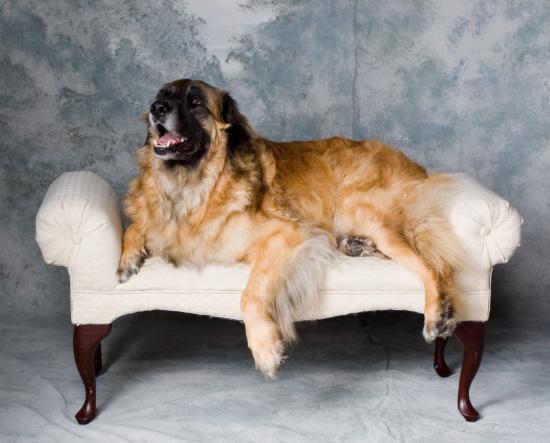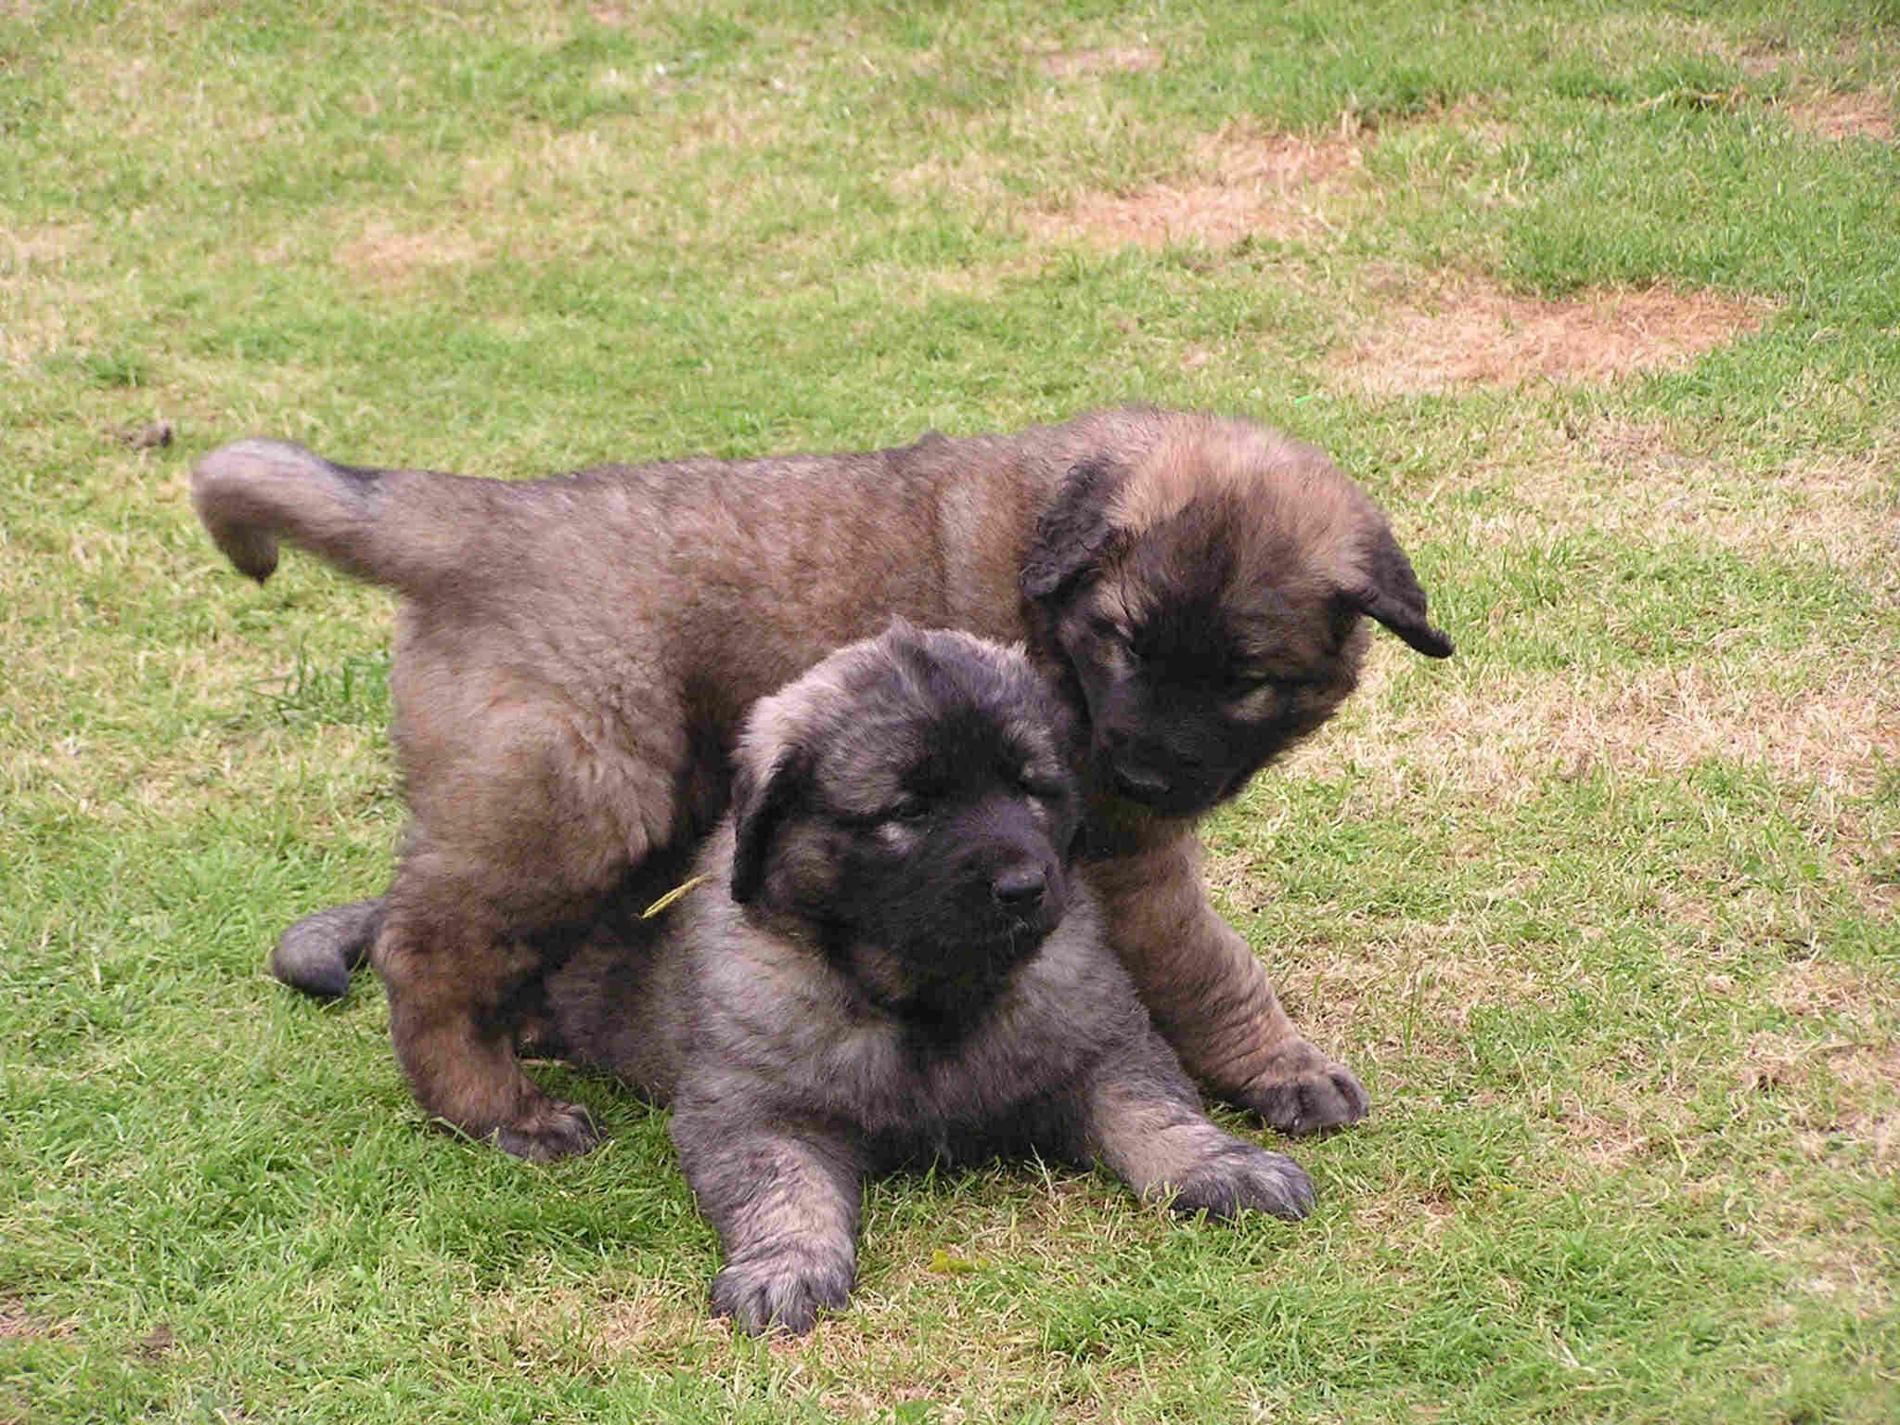The first image is the image on the left, the second image is the image on the right. Analyze the images presented: Is the assertion "One image is shot indoors with furniture and one image is outdoors with grass." valid? Answer yes or no. Yes. The first image is the image on the left, the second image is the image on the right. Assess this claim about the two images: "There are two dogs total.". Correct or not? Answer yes or no. No. 